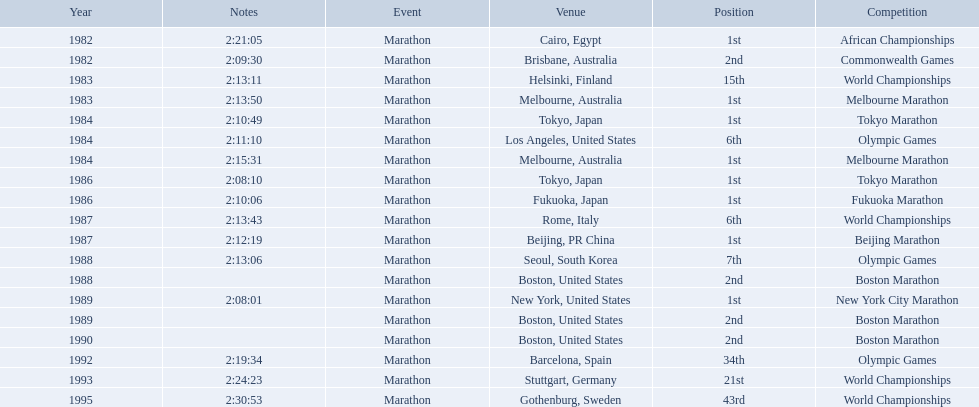What are all of the juma ikangaa competitions? African Championships, Commonwealth Games, World Championships, Melbourne Marathon, Tokyo Marathon, Olympic Games, Melbourne Marathon, Tokyo Marathon, Fukuoka Marathon, World Championships, Beijing Marathon, Olympic Games, Boston Marathon, New York City Marathon, Boston Marathon, Boston Marathon, Olympic Games, World Championships, World Championships. Which of these competitions did not take place in the united states? African Championships, Commonwealth Games, World Championships, Melbourne Marathon, Tokyo Marathon, Melbourne Marathon, Tokyo Marathon, Fukuoka Marathon, World Championships, Beijing Marathon, Olympic Games, Olympic Games, World Championships, World Championships. Out of these, which of them took place in asia? Tokyo Marathon, Tokyo Marathon, Fukuoka Marathon, Beijing Marathon, Olympic Games. Which of the remaining competitions took place in china? Beijing Marathon. 